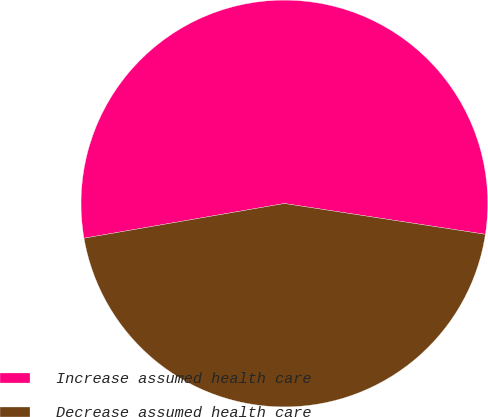<chart> <loc_0><loc_0><loc_500><loc_500><pie_chart><fcel>Increase assumed health care<fcel>Decrease assumed health care<nl><fcel>55.15%<fcel>44.85%<nl></chart> 